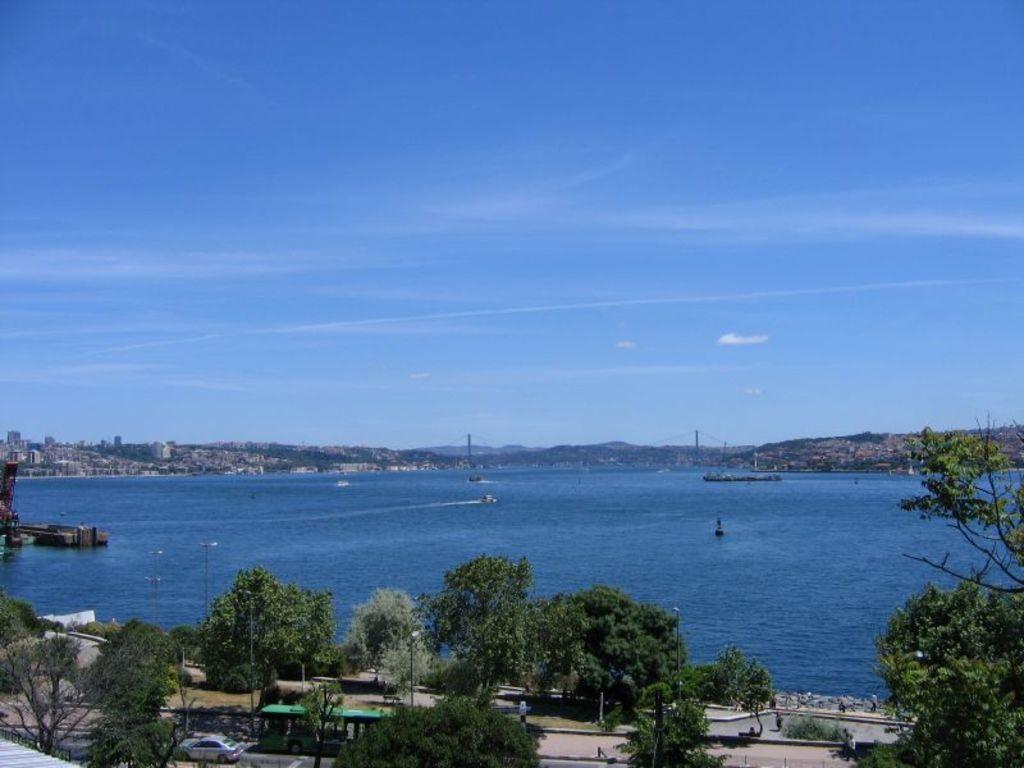How would you summarize this image in a sentence or two? In this picture there is a beautiful view of the lake. In the front there is a lake water and white color boats. In the background there are some houses and trees. In the front we can see some trees and green color bus moving on the road. 